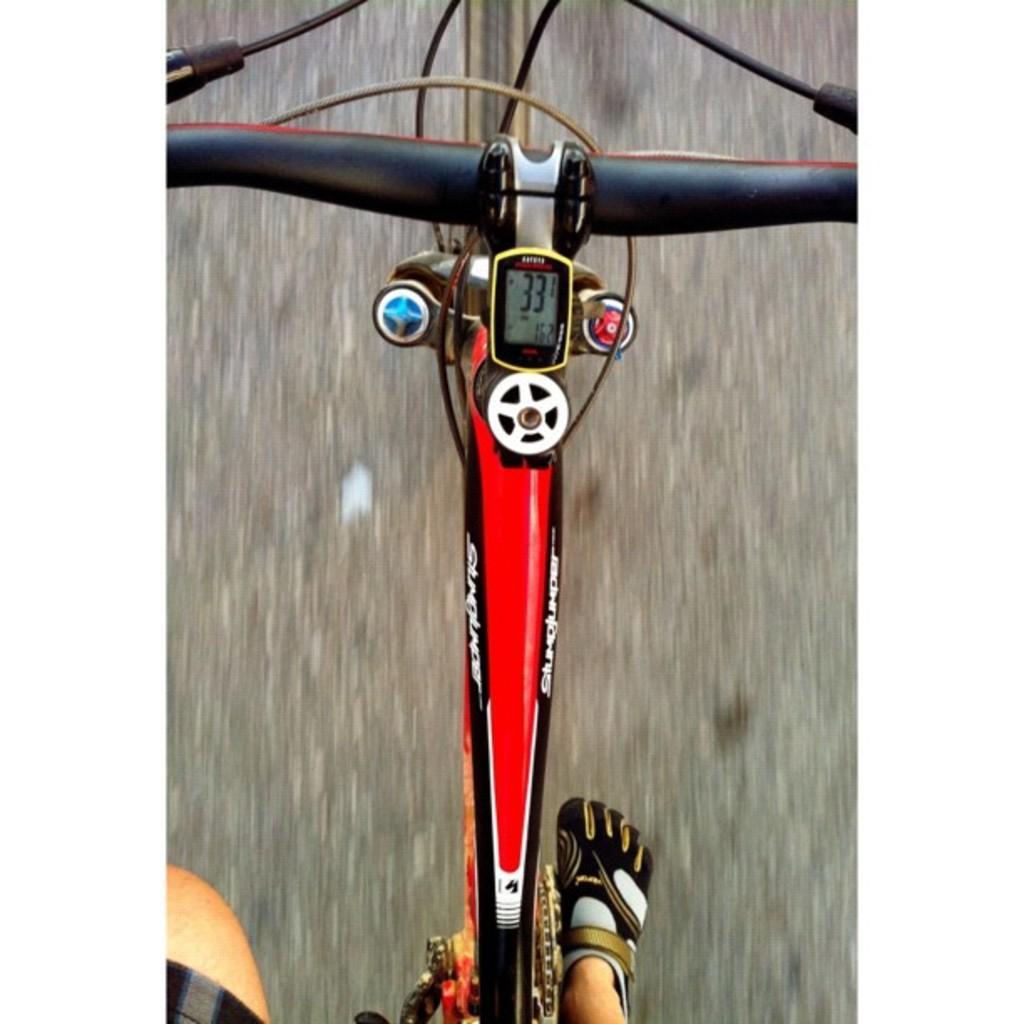Could you give a brief overview of what you see in this image? In this image we can see some person riding the bicycle. We can also see speedometer. In the background we can see the road. 